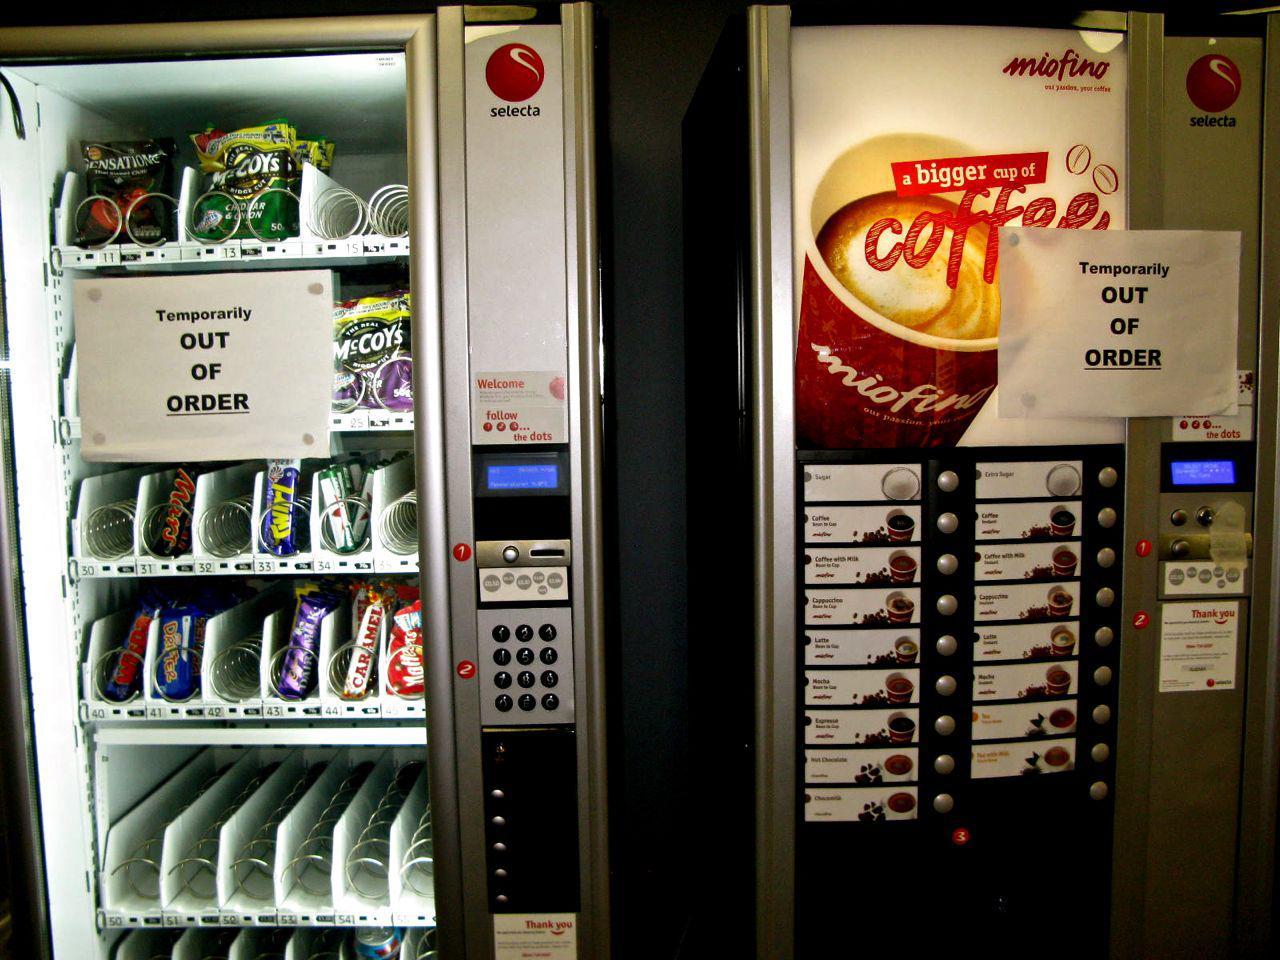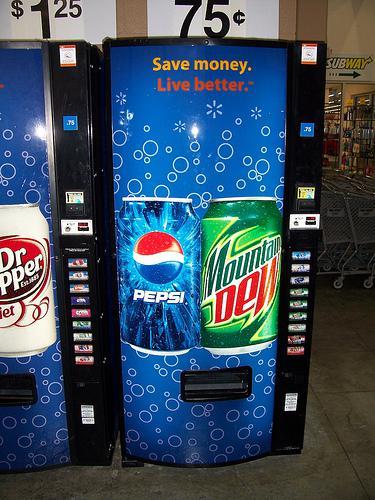The first image is the image on the left, the second image is the image on the right. Analyze the images presented: Is the assertion "The vending machine in the right image is predominately green." valid? Answer yes or no. No. The first image is the image on the left, the second image is the image on the right. For the images shown, is this caption "An image features a standalone vending machine with greenish sides that include a logo towards the top." true? Answer yes or no. No. 